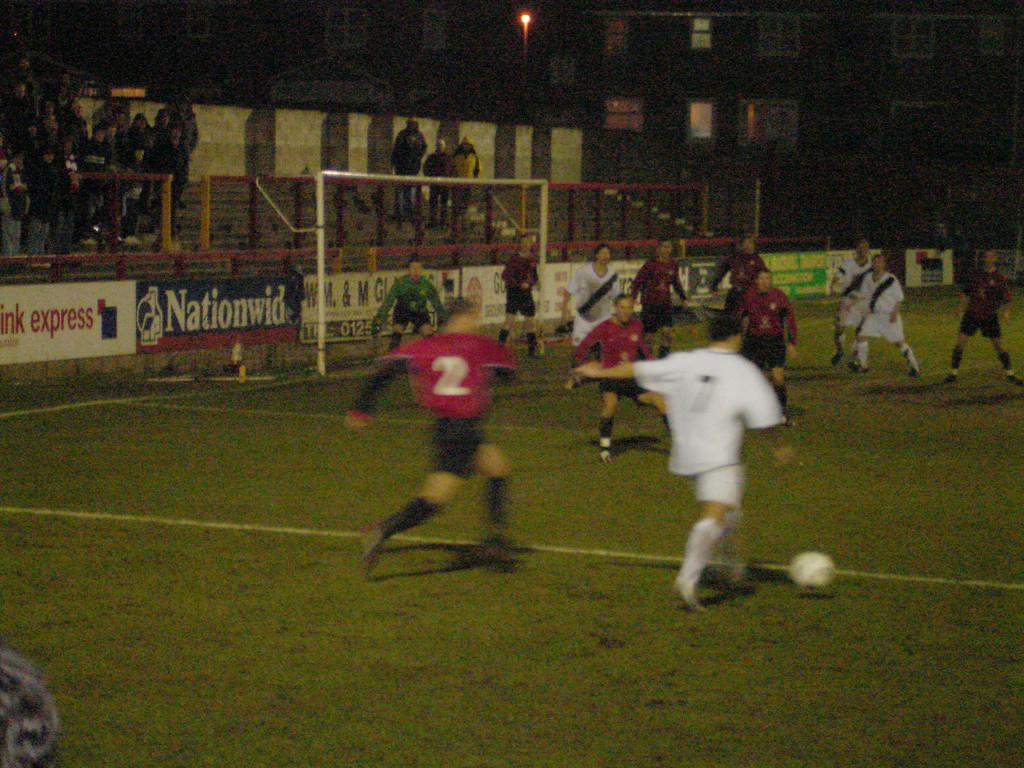What sport are the players engaged in within the image? The players are playing football in the image. Where is the football game taking place? The football game is taking place on a ground. What can be seen in the background of the image? There are boards and people visible in the background of the image. What type of creature is playing a trick on the players in the image? There is no creature present in the image, nor is there any mention of a trick being played on the players. 